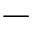<formula> <loc_0><loc_0><loc_500><loc_500>-</formula> 